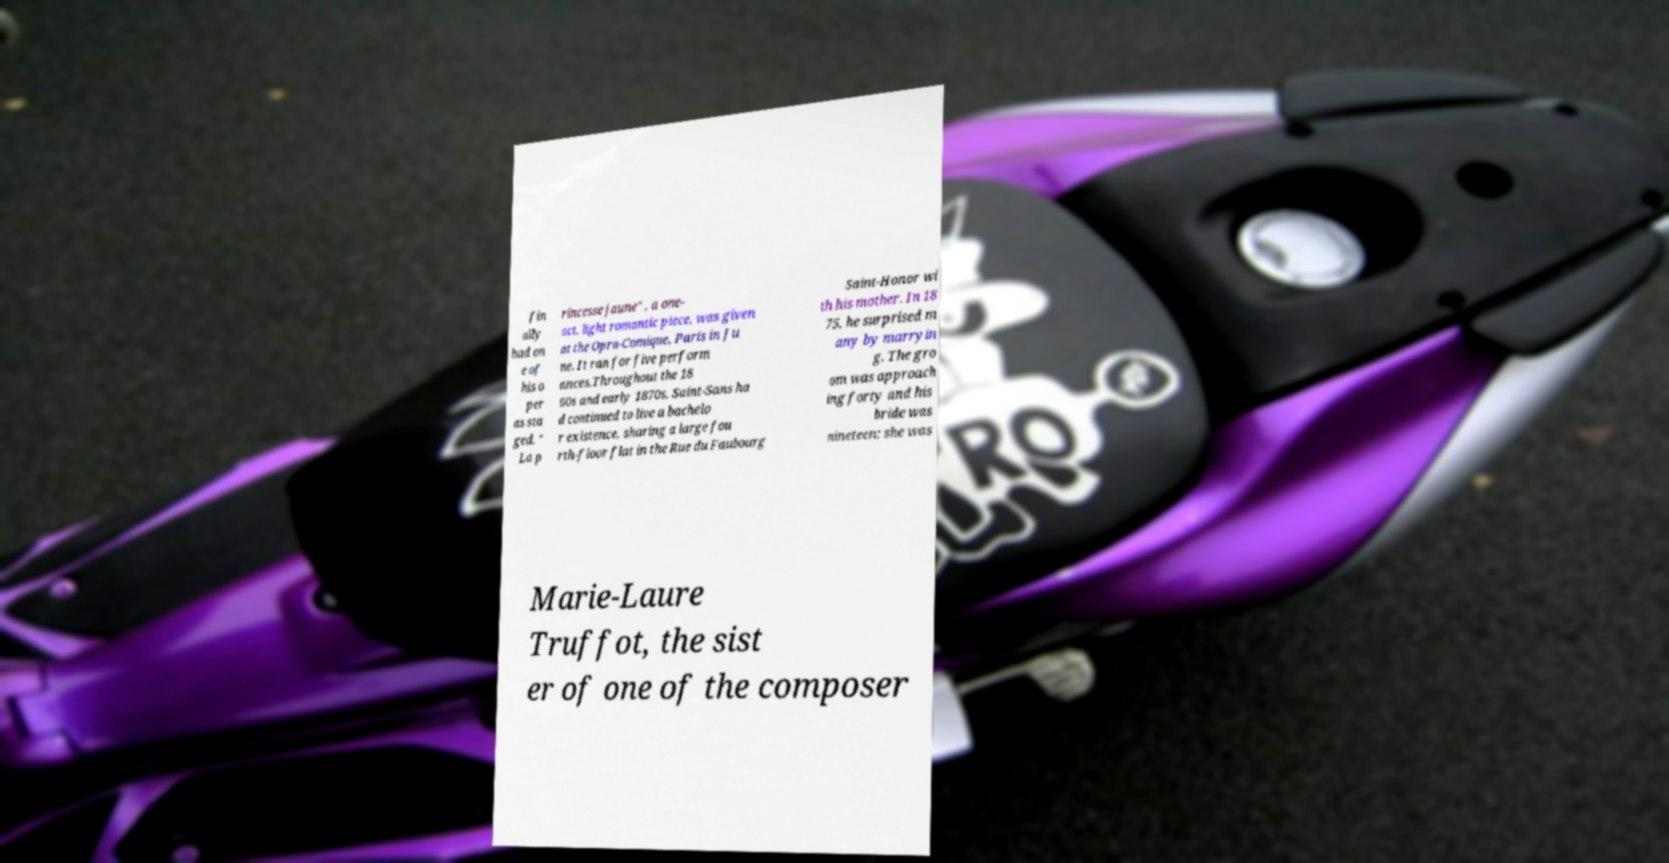Could you assist in decoding the text presented in this image and type it out clearly? fin ally had on e of his o per as sta ged. " La p rincesse jaune" , a one- act, light romantic piece, was given at the Opra-Comique, Paris in Ju ne. It ran for five perform ances.Throughout the 18 60s and early 1870s, Saint-Sans ha d continued to live a bachelo r existence, sharing a large fou rth-floor flat in the Rue du Faubourg Saint-Honor wi th his mother. In 18 75, he surprised m any by marryin g. The gro om was approach ing forty and his bride was nineteen; she was Marie-Laure Truffot, the sist er of one of the composer 